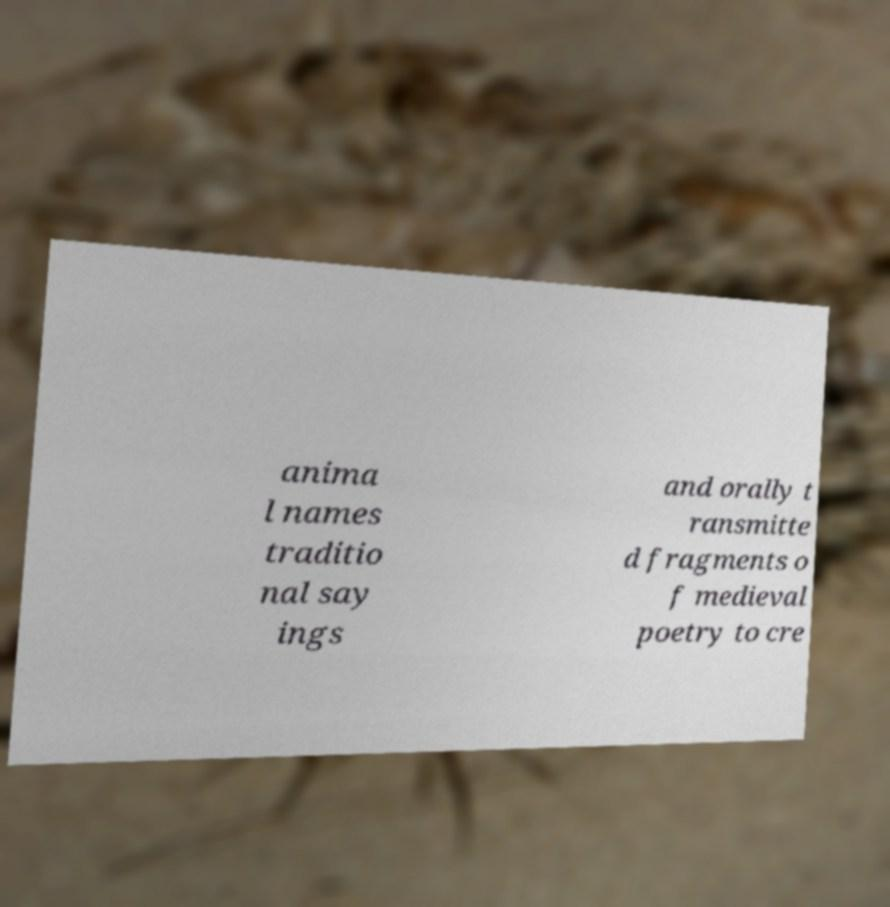Please identify and transcribe the text found in this image. anima l names traditio nal say ings and orally t ransmitte d fragments o f medieval poetry to cre 